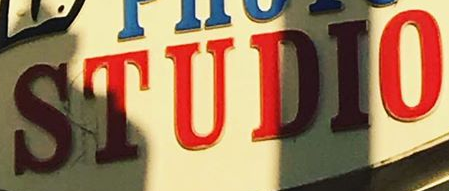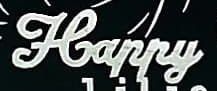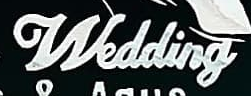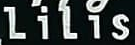What words can you see in these images in sequence, separated by a semicolon? STUDIO; Happy; Wedding; LiLis 